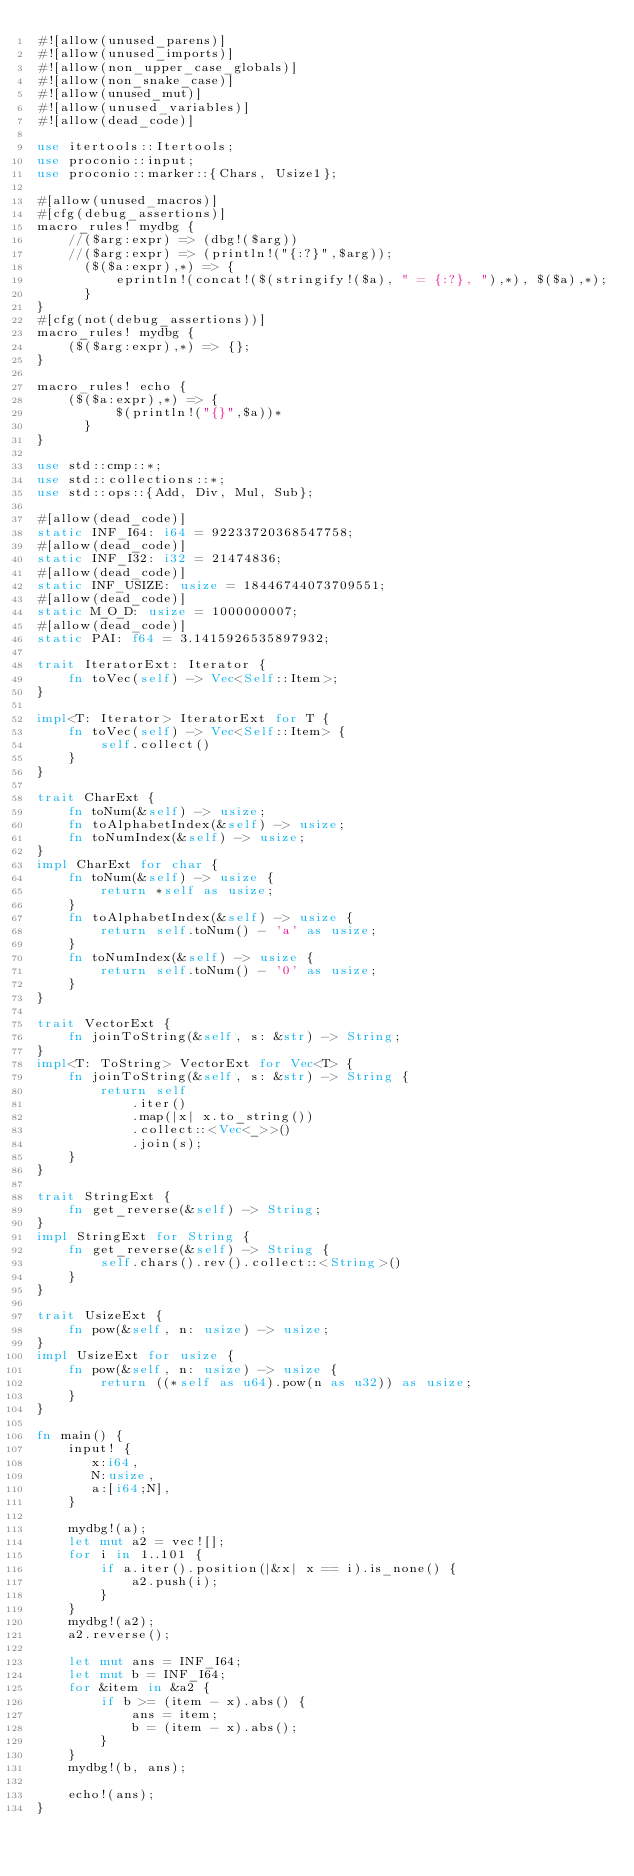<code> <loc_0><loc_0><loc_500><loc_500><_Rust_>#![allow(unused_parens)]
#![allow(unused_imports)]
#![allow(non_upper_case_globals)]
#![allow(non_snake_case)]
#![allow(unused_mut)]
#![allow(unused_variables)]
#![allow(dead_code)]

use itertools::Itertools;
use proconio::input;
use proconio::marker::{Chars, Usize1};

#[allow(unused_macros)]
#[cfg(debug_assertions)]
macro_rules! mydbg {
    //($arg:expr) => (dbg!($arg))
    //($arg:expr) => (println!("{:?}",$arg));
      ($($a:expr),*) => {
          eprintln!(concat!($(stringify!($a), " = {:?}, "),*), $($a),*);
      }
}
#[cfg(not(debug_assertions))]
macro_rules! mydbg {
    ($($arg:expr),*) => {};
}

macro_rules! echo {
    ($($a:expr),*) => {
          $(println!("{}",$a))*
      }
}

use std::cmp::*;
use std::collections::*;
use std::ops::{Add, Div, Mul, Sub};

#[allow(dead_code)]
static INF_I64: i64 = 92233720368547758;
#[allow(dead_code)]
static INF_I32: i32 = 21474836;
#[allow(dead_code)]
static INF_USIZE: usize = 18446744073709551;
#[allow(dead_code)]
static M_O_D: usize = 1000000007;
#[allow(dead_code)]
static PAI: f64 = 3.1415926535897932;

trait IteratorExt: Iterator {
    fn toVec(self) -> Vec<Self::Item>;
}

impl<T: Iterator> IteratorExt for T {
    fn toVec(self) -> Vec<Self::Item> {
        self.collect()
    }
}

trait CharExt {
    fn toNum(&self) -> usize;
    fn toAlphabetIndex(&self) -> usize;
    fn toNumIndex(&self) -> usize;
}
impl CharExt for char {
    fn toNum(&self) -> usize {
        return *self as usize;
    }
    fn toAlphabetIndex(&self) -> usize {
        return self.toNum() - 'a' as usize;
    }
    fn toNumIndex(&self) -> usize {
        return self.toNum() - '0' as usize;
    }
}

trait VectorExt {
    fn joinToString(&self, s: &str) -> String;
}
impl<T: ToString> VectorExt for Vec<T> {
    fn joinToString(&self, s: &str) -> String {
        return self
            .iter()
            .map(|x| x.to_string())
            .collect::<Vec<_>>()
            .join(s);
    }
}

trait StringExt {
    fn get_reverse(&self) -> String;
}
impl StringExt for String {
    fn get_reverse(&self) -> String {
        self.chars().rev().collect::<String>()
    }
}

trait UsizeExt {
    fn pow(&self, n: usize) -> usize;
}
impl UsizeExt for usize {
    fn pow(&self, n: usize) -> usize {
        return ((*self as u64).pow(n as u32)) as usize;
    }
}

fn main() {
    input! {
       x:i64,
       N:usize,
       a:[i64;N],
    }

    mydbg!(a);
    let mut a2 = vec![];
    for i in 1..101 {
        if a.iter().position(|&x| x == i).is_none() {
            a2.push(i);
        }
    }
    mydbg!(a2);
    a2.reverse();

    let mut ans = INF_I64;
    let mut b = INF_I64;
    for &item in &a2 {
        if b >= (item - x).abs() {
            ans = item;
            b = (item - x).abs();
        }
    }
    mydbg!(b, ans);

    echo!(ans);
}
</code> 